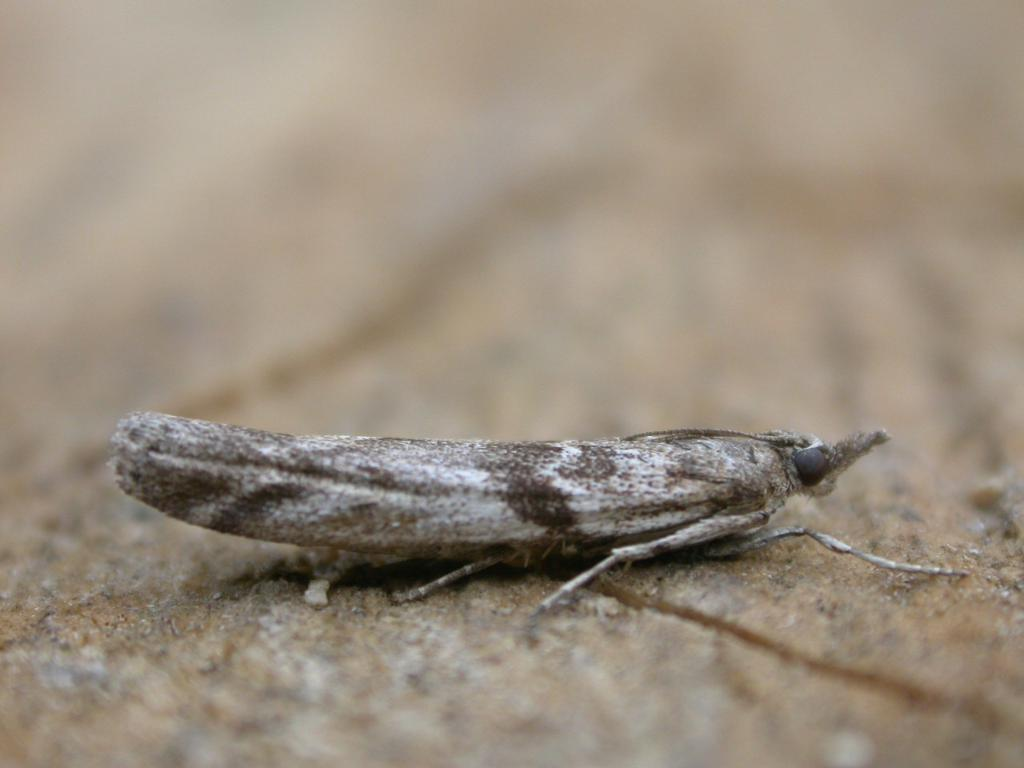What type of creature can be seen in the image? There is an insect in the image. Where is the insect located in the image? The insect appears to be standing on the ground. Can you describe the background of the image? The background of the image is blurry. What type of veil can be seen covering the insect in the image? There is no veil present in the image; the insect is not covered. What is the insect doing that causes it to laugh in the image? The insect is not laughing in the image, as insects do not have the ability to laugh. 